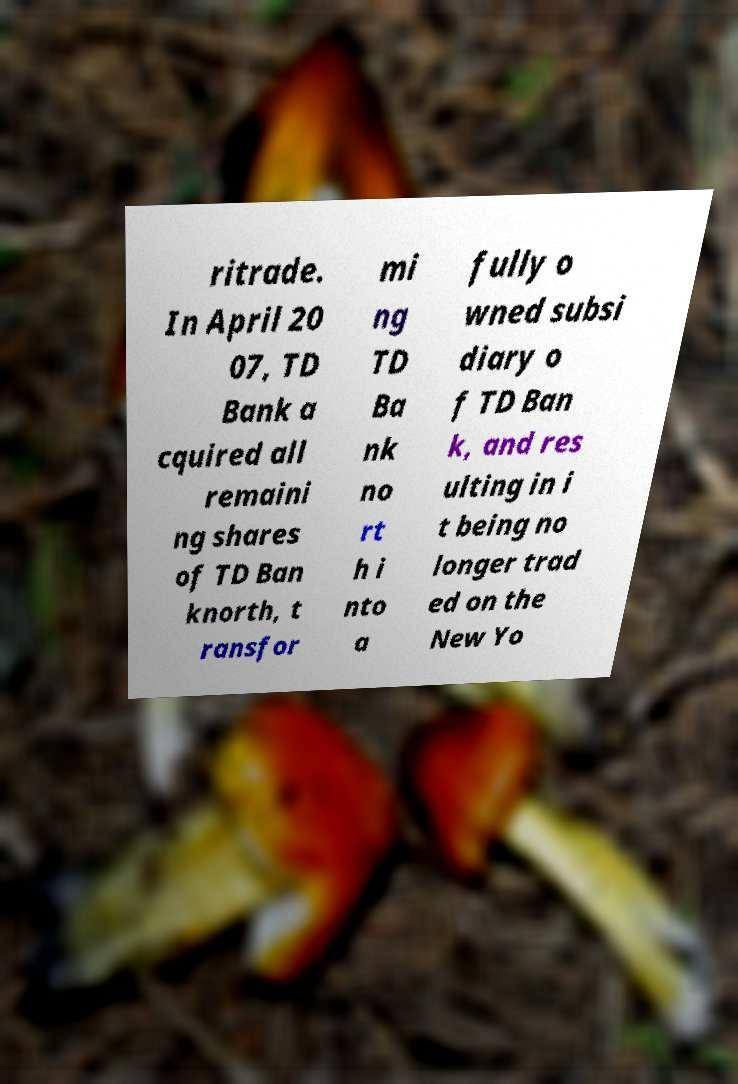Please identify and transcribe the text found in this image. ritrade. In April 20 07, TD Bank a cquired all remaini ng shares of TD Ban knorth, t ransfor mi ng TD Ba nk no rt h i nto a fully o wned subsi diary o f TD Ban k, and res ulting in i t being no longer trad ed on the New Yo 